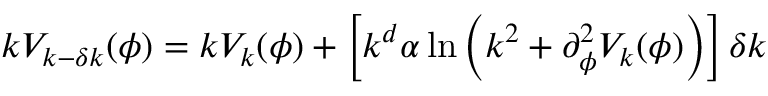Convert formula to latex. <formula><loc_0><loc_0><loc_500><loc_500>k V _ { k - \delta k } ( \phi ) = k V _ { k } ( \phi ) + \left [ k ^ { d } \alpha \ln \left ( k ^ { 2 } + \partial _ { \phi } ^ { 2 } V _ { k } ( \phi ) \right ) \right ] \delta k</formula> 